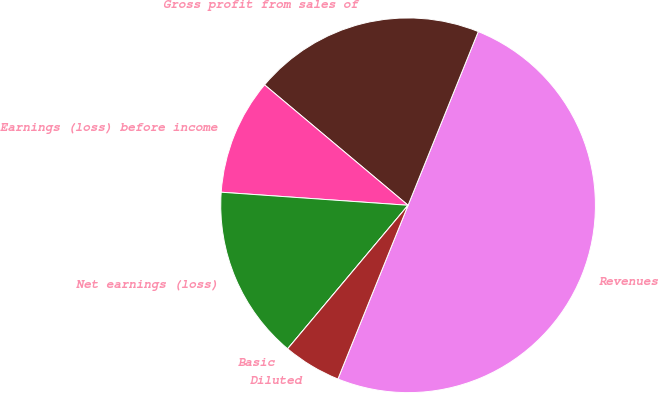Convert chart to OTSL. <chart><loc_0><loc_0><loc_500><loc_500><pie_chart><fcel>Revenues<fcel>Gross profit from sales of<fcel>Earnings (loss) before income<fcel>Net earnings (loss)<fcel>Basic<fcel>Diluted<nl><fcel>50.0%<fcel>20.0%<fcel>10.0%<fcel>15.0%<fcel>0.0%<fcel>5.0%<nl></chart> 